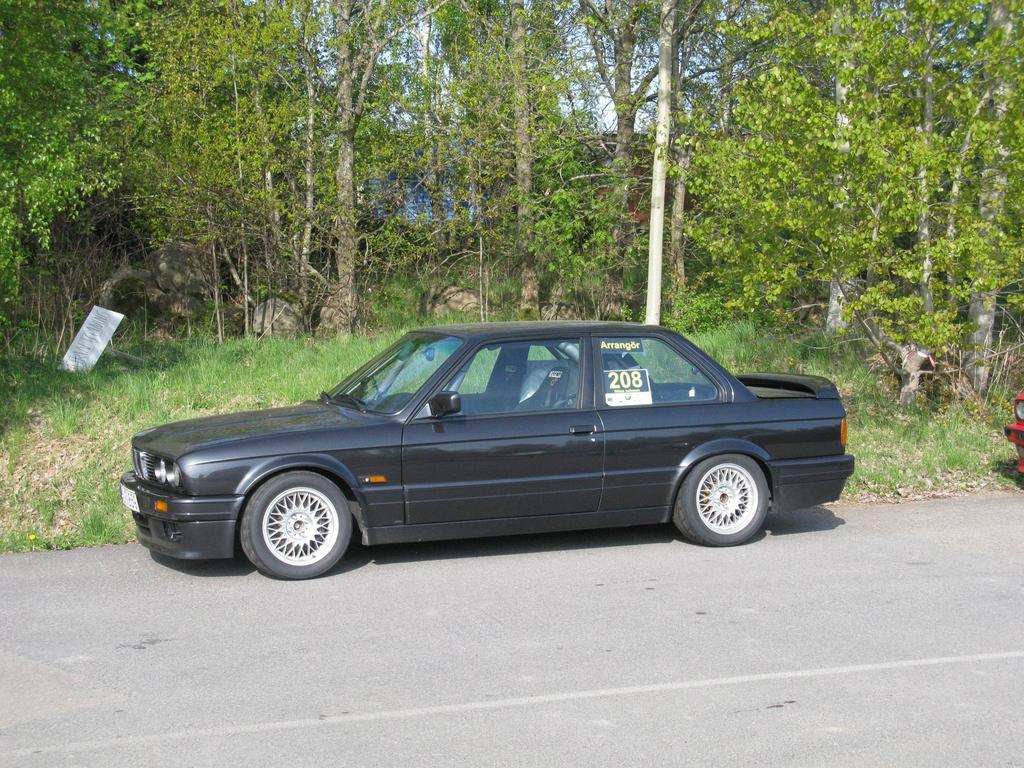What type of vehicle is in the image? There is a black car in the image. What can be seen in the background of the image? There are trees in the background of the image. What is the color of the trees? The trees are green. What is visible above the trees in the image? The sky is visible in the image. What colors can be seen in the sky? The sky has both white and blue colors. Where is the carriage located in the image? There is no carriage present in the image. What type of art can be seen hanging on the walls in the image? There are no walls or art present in the image; it features a black car, trees, and a sky. 